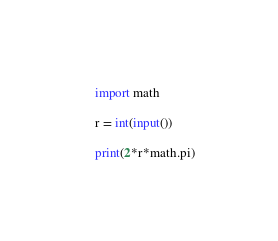Convert code to text. <code><loc_0><loc_0><loc_500><loc_500><_Python_>import math

r = int(input())

print(2*r*math.pi)</code> 